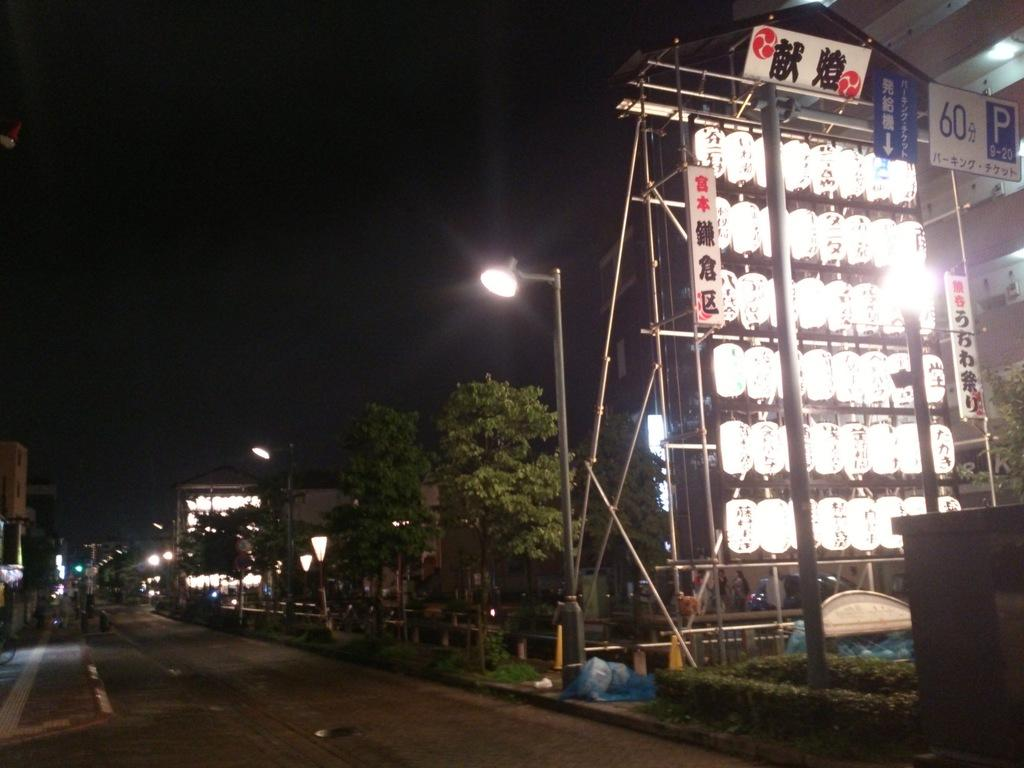<image>
Share a concise interpretation of the image provided. many lights are on a sign and at the top is a P and 60 